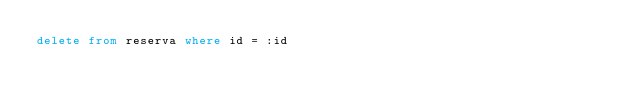Convert code to text. <code><loc_0><loc_0><loc_500><loc_500><_SQL_>delete from reserva where id = :id</code> 